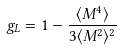Convert formula to latex. <formula><loc_0><loc_0><loc_500><loc_500>g _ { L } = 1 - \frac { \langle M ^ { 4 } \rangle } { 3 \langle M ^ { 2 } \rangle ^ { 2 } }</formula> 